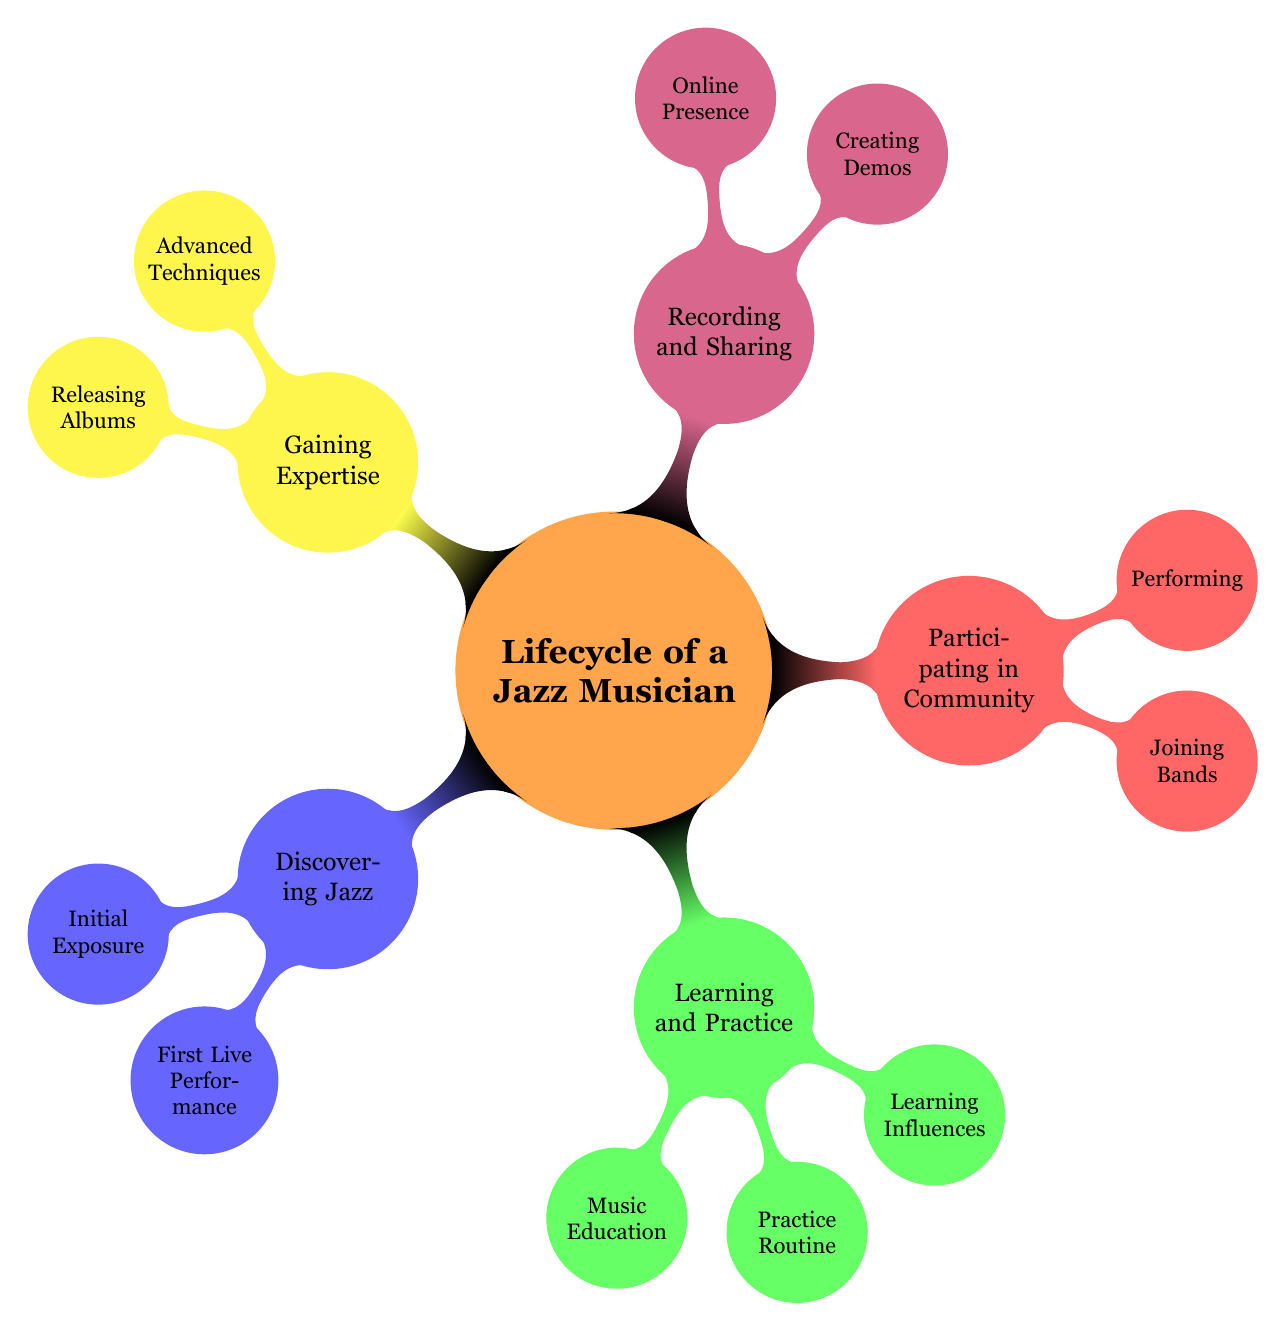What is the first stage in the lifecycle of a jazz musician? The first stage is represented by the node "Discovering Jazz" in the diagram, indicating that this is the initial step in the lifecycle.
Answer: Discovering Jazz How many main stages are present in the lifecycle of a jazz musician? By counting the main nodes at the first level of the diagram, we identify five stages represented: "Discovering Jazz," "Learning and Practice," "Participating in Community," "Recording and Sharing," and "Gaining Expertise."
Answer: 5 What type of activities are included under "Creating Demos"? The node "Creating Demos" includes two activities: "Home Studio Setup" and "Collaboration with Local Recording Studios." These represent the specific actions taken during the demo creation stage.
Answer: Home Studio Setup, Collaboration with Local Recording Studios Which subcategory includes "Joining University Jazz Ensemble"? The activity "Joining University Jazz Ensemble" is found under the "Joining Bands" node, which is a subcategory of "Participating in Community." This shows how musicians become involved in collaborative settings.
Answer: Joining Bands What is the relationship between "Music Education" and the "Learning and Practice" stage? "Music Education" is a key component of the "Learning and Practice" stage, indicating that acquiring formal musical knowledge is essential during this phase. This relationship highlights a foundational aspect of the lifecycle.
Answer: Music Education Which renowned musicians could be associated with the "Masterclasses" under "Gaining Expertise"? The node "Advanced Techniques" under "Gaining Expertise" refers to "Masterclasses with Renowned Jazz Musicians," which implies that well-known figures in jazz likely conduct these masterclasses, adding another layer of expertise for musicians.
Answer: Renowned Jazz Musicians What online platforms are indicated in the "Online Presence" node? The "Online Presence" node specifically mentions "Uploading to SoundCloud" and "Sharing on Social Media" as activities, denoting the importance of online visibility for jazz musicians.
Answer: Uploading to SoundCloud, Sharing on Social Media In which node can you find "Attending Jazz Workshops"? The activity "Attending Jazz Workshops" is located under the "Learning Influences" category, which falls within the "Learning and Practice" stage, emphasizing the learning experience musicians gain from community events.
Answer: Learning Influences 